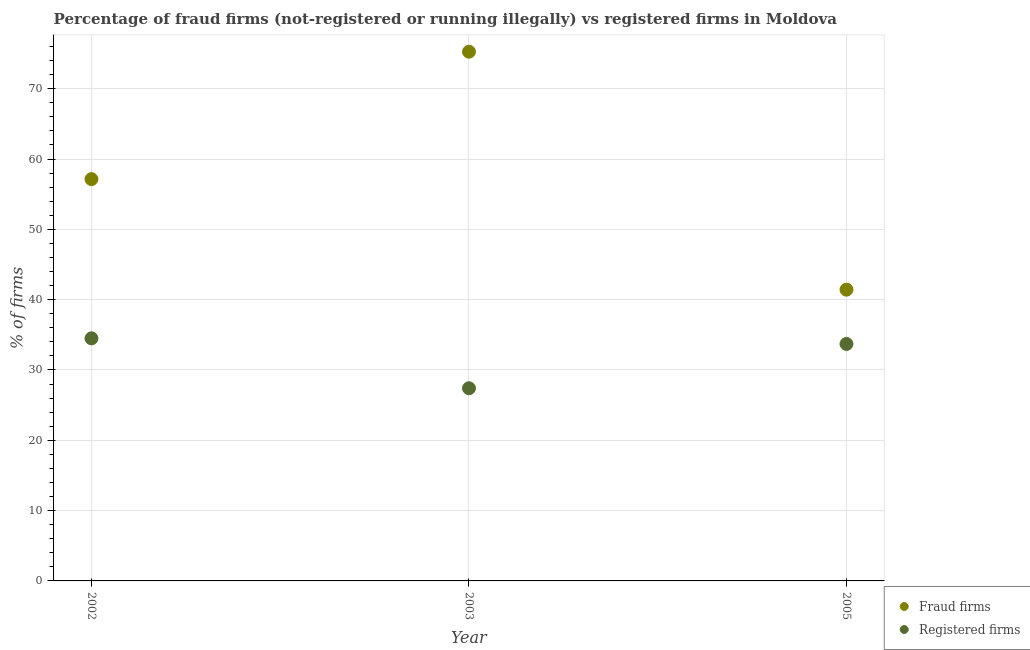What is the percentage of fraud firms in 2005?
Provide a short and direct response. 41.42. Across all years, what is the maximum percentage of fraud firms?
Give a very brief answer. 75.26. Across all years, what is the minimum percentage of registered firms?
Offer a terse response. 27.4. What is the total percentage of fraud firms in the graph?
Ensure brevity in your answer.  173.82. What is the difference between the percentage of registered firms in 2002 and that in 2003?
Provide a short and direct response. 7.1. What is the difference between the percentage of registered firms in 2003 and the percentage of fraud firms in 2005?
Offer a terse response. -14.02. What is the average percentage of registered firms per year?
Your response must be concise. 31.87. In the year 2002, what is the difference between the percentage of fraud firms and percentage of registered firms?
Your answer should be compact. 22.64. In how many years, is the percentage of registered firms greater than 22 %?
Your answer should be very brief. 3. What is the ratio of the percentage of fraud firms in 2002 to that in 2005?
Offer a very short reply. 1.38. What is the difference between the highest and the second highest percentage of registered firms?
Give a very brief answer. 0.8. What is the difference between the highest and the lowest percentage of registered firms?
Offer a very short reply. 7.1. In how many years, is the percentage of registered firms greater than the average percentage of registered firms taken over all years?
Make the answer very short. 2. Is the sum of the percentage of registered firms in 2002 and 2005 greater than the maximum percentage of fraud firms across all years?
Give a very brief answer. No. Is the percentage of registered firms strictly greater than the percentage of fraud firms over the years?
Give a very brief answer. No. How many years are there in the graph?
Give a very brief answer. 3. What is the difference between two consecutive major ticks on the Y-axis?
Offer a very short reply. 10. Are the values on the major ticks of Y-axis written in scientific E-notation?
Give a very brief answer. No. Does the graph contain grids?
Your answer should be compact. Yes. What is the title of the graph?
Provide a succinct answer. Percentage of fraud firms (not-registered or running illegally) vs registered firms in Moldova. What is the label or title of the X-axis?
Your response must be concise. Year. What is the label or title of the Y-axis?
Your response must be concise. % of firms. What is the % of firms of Fraud firms in 2002?
Provide a short and direct response. 57.14. What is the % of firms of Registered firms in 2002?
Ensure brevity in your answer.  34.5. What is the % of firms in Fraud firms in 2003?
Ensure brevity in your answer.  75.26. What is the % of firms of Registered firms in 2003?
Your answer should be compact. 27.4. What is the % of firms in Fraud firms in 2005?
Your response must be concise. 41.42. What is the % of firms of Registered firms in 2005?
Ensure brevity in your answer.  33.7. Across all years, what is the maximum % of firms of Fraud firms?
Provide a succinct answer. 75.26. Across all years, what is the maximum % of firms in Registered firms?
Make the answer very short. 34.5. Across all years, what is the minimum % of firms in Fraud firms?
Provide a short and direct response. 41.42. Across all years, what is the minimum % of firms of Registered firms?
Give a very brief answer. 27.4. What is the total % of firms in Fraud firms in the graph?
Your answer should be compact. 173.82. What is the total % of firms of Registered firms in the graph?
Your response must be concise. 95.6. What is the difference between the % of firms in Fraud firms in 2002 and that in 2003?
Your response must be concise. -18.12. What is the difference between the % of firms of Fraud firms in 2002 and that in 2005?
Your response must be concise. 15.72. What is the difference between the % of firms of Fraud firms in 2003 and that in 2005?
Your answer should be compact. 33.84. What is the difference between the % of firms in Registered firms in 2003 and that in 2005?
Make the answer very short. -6.3. What is the difference between the % of firms in Fraud firms in 2002 and the % of firms in Registered firms in 2003?
Offer a terse response. 29.74. What is the difference between the % of firms of Fraud firms in 2002 and the % of firms of Registered firms in 2005?
Ensure brevity in your answer.  23.44. What is the difference between the % of firms in Fraud firms in 2003 and the % of firms in Registered firms in 2005?
Keep it short and to the point. 41.56. What is the average % of firms of Fraud firms per year?
Provide a succinct answer. 57.94. What is the average % of firms of Registered firms per year?
Your response must be concise. 31.87. In the year 2002, what is the difference between the % of firms in Fraud firms and % of firms in Registered firms?
Provide a succinct answer. 22.64. In the year 2003, what is the difference between the % of firms of Fraud firms and % of firms of Registered firms?
Provide a succinct answer. 47.86. In the year 2005, what is the difference between the % of firms of Fraud firms and % of firms of Registered firms?
Provide a short and direct response. 7.72. What is the ratio of the % of firms of Fraud firms in 2002 to that in 2003?
Offer a terse response. 0.76. What is the ratio of the % of firms in Registered firms in 2002 to that in 2003?
Provide a succinct answer. 1.26. What is the ratio of the % of firms in Fraud firms in 2002 to that in 2005?
Offer a terse response. 1.38. What is the ratio of the % of firms of Registered firms in 2002 to that in 2005?
Your response must be concise. 1.02. What is the ratio of the % of firms in Fraud firms in 2003 to that in 2005?
Ensure brevity in your answer.  1.82. What is the ratio of the % of firms in Registered firms in 2003 to that in 2005?
Provide a succinct answer. 0.81. What is the difference between the highest and the second highest % of firms of Fraud firms?
Keep it short and to the point. 18.12. What is the difference between the highest and the lowest % of firms in Fraud firms?
Provide a short and direct response. 33.84. 